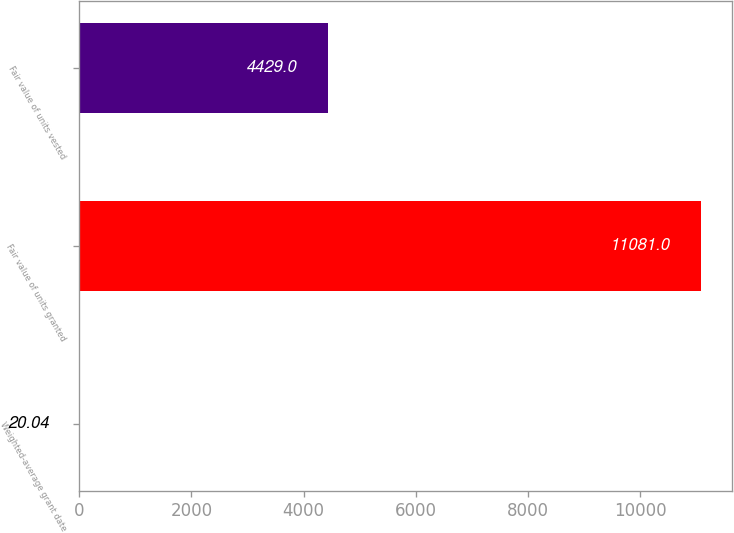Convert chart. <chart><loc_0><loc_0><loc_500><loc_500><bar_chart><fcel>Weighted-average grant date<fcel>Fair value of units granted<fcel>Fair value of units vested<nl><fcel>20.04<fcel>11081<fcel>4429<nl></chart> 